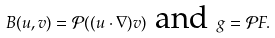<formula> <loc_0><loc_0><loc_500><loc_500>B ( u , v ) = \mathcal { P } ( ( u \cdot \nabla ) v ) \text { and } g = \mathcal { P } F .</formula> 